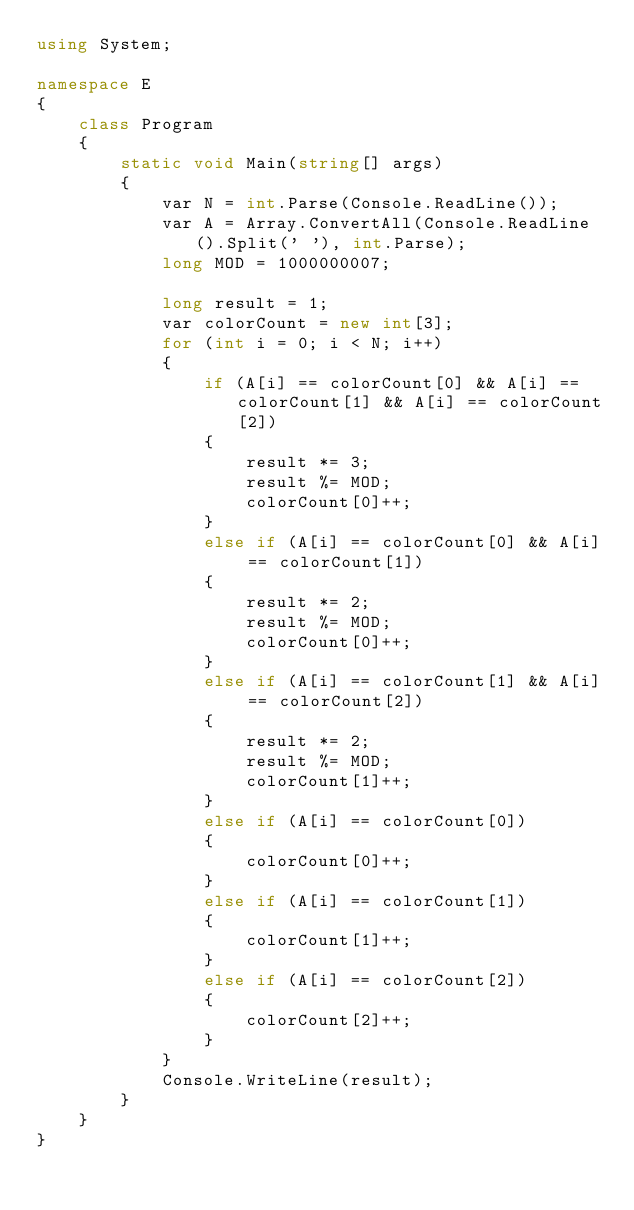<code> <loc_0><loc_0><loc_500><loc_500><_C#_>using System;

namespace E
{
    class Program
    {
        static void Main(string[] args)
        {
            var N = int.Parse(Console.ReadLine());
            var A = Array.ConvertAll(Console.ReadLine().Split(' '), int.Parse);
            long MOD = 1000000007;

            long result = 1;
            var colorCount = new int[3];
            for (int i = 0; i < N; i++)
            {
                if (A[i] == colorCount[0] && A[i] == colorCount[1] && A[i] == colorCount[2])
                {
                    result *= 3;
                    result %= MOD;
                    colorCount[0]++;
                }
                else if (A[i] == colorCount[0] && A[i] == colorCount[1])
                {
                    result *= 2;
                    result %= MOD;
                    colorCount[0]++;
                }
                else if (A[i] == colorCount[1] && A[i] == colorCount[2])
                {
                    result *= 2;
                    result %= MOD;
                    colorCount[1]++;
                }
                else if (A[i] == colorCount[0])
                {
                    colorCount[0]++;
                }
                else if (A[i] == colorCount[1])
                {
                    colorCount[1]++;
                }
                else if (A[i] == colorCount[2])
                {
                    colorCount[2]++;
                }
            }
            Console.WriteLine(result);
        }
    }
}
</code> 